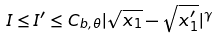Convert formula to latex. <formula><loc_0><loc_0><loc_500><loc_500>I \leq I ^ { \prime } \leq C _ { b , \theta } | \sqrt { x _ { 1 } } - \sqrt { x _ { 1 } ^ { \prime } } | ^ { \gamma }</formula> 